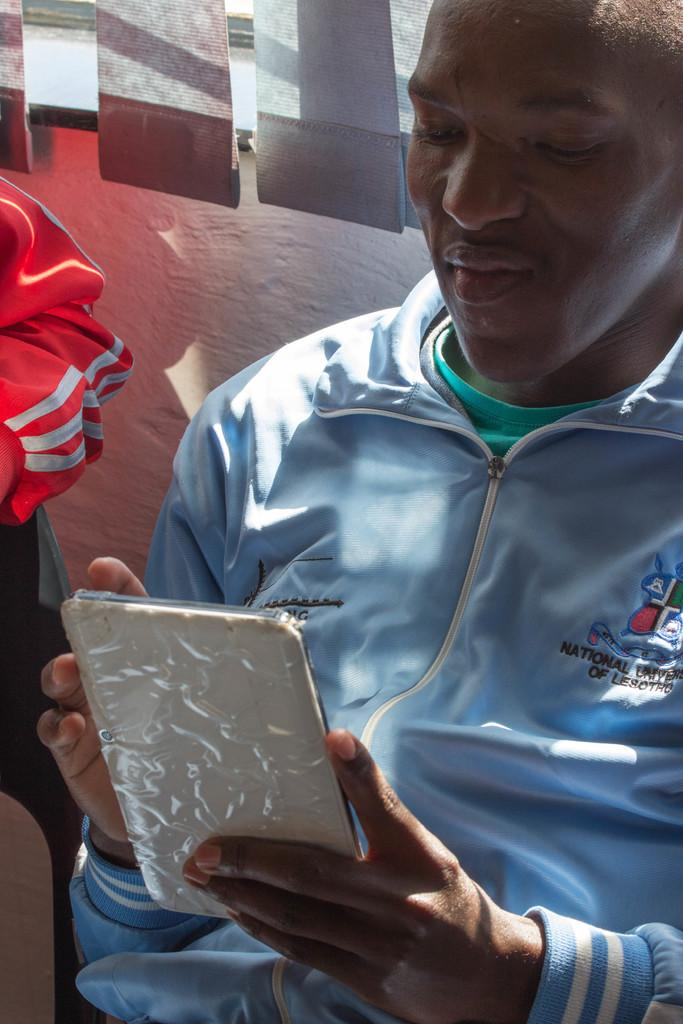What is the person in the image wearing? The person is wearing a blue jacket. What is the person holding in the image? The person is holding a mobile. Can you describe the hand visible on the left side of the image? There is a hand of another person visible on the left side of the image. What is located at the top of the image? There is a window at the top of the image. What type of window covering is present in the image? Window blinds are present in the image. Are there any fairies visible in the image? No, there are no fairies present in the image. What type of stove can be seen in the image? There is no stove visible in the image. 